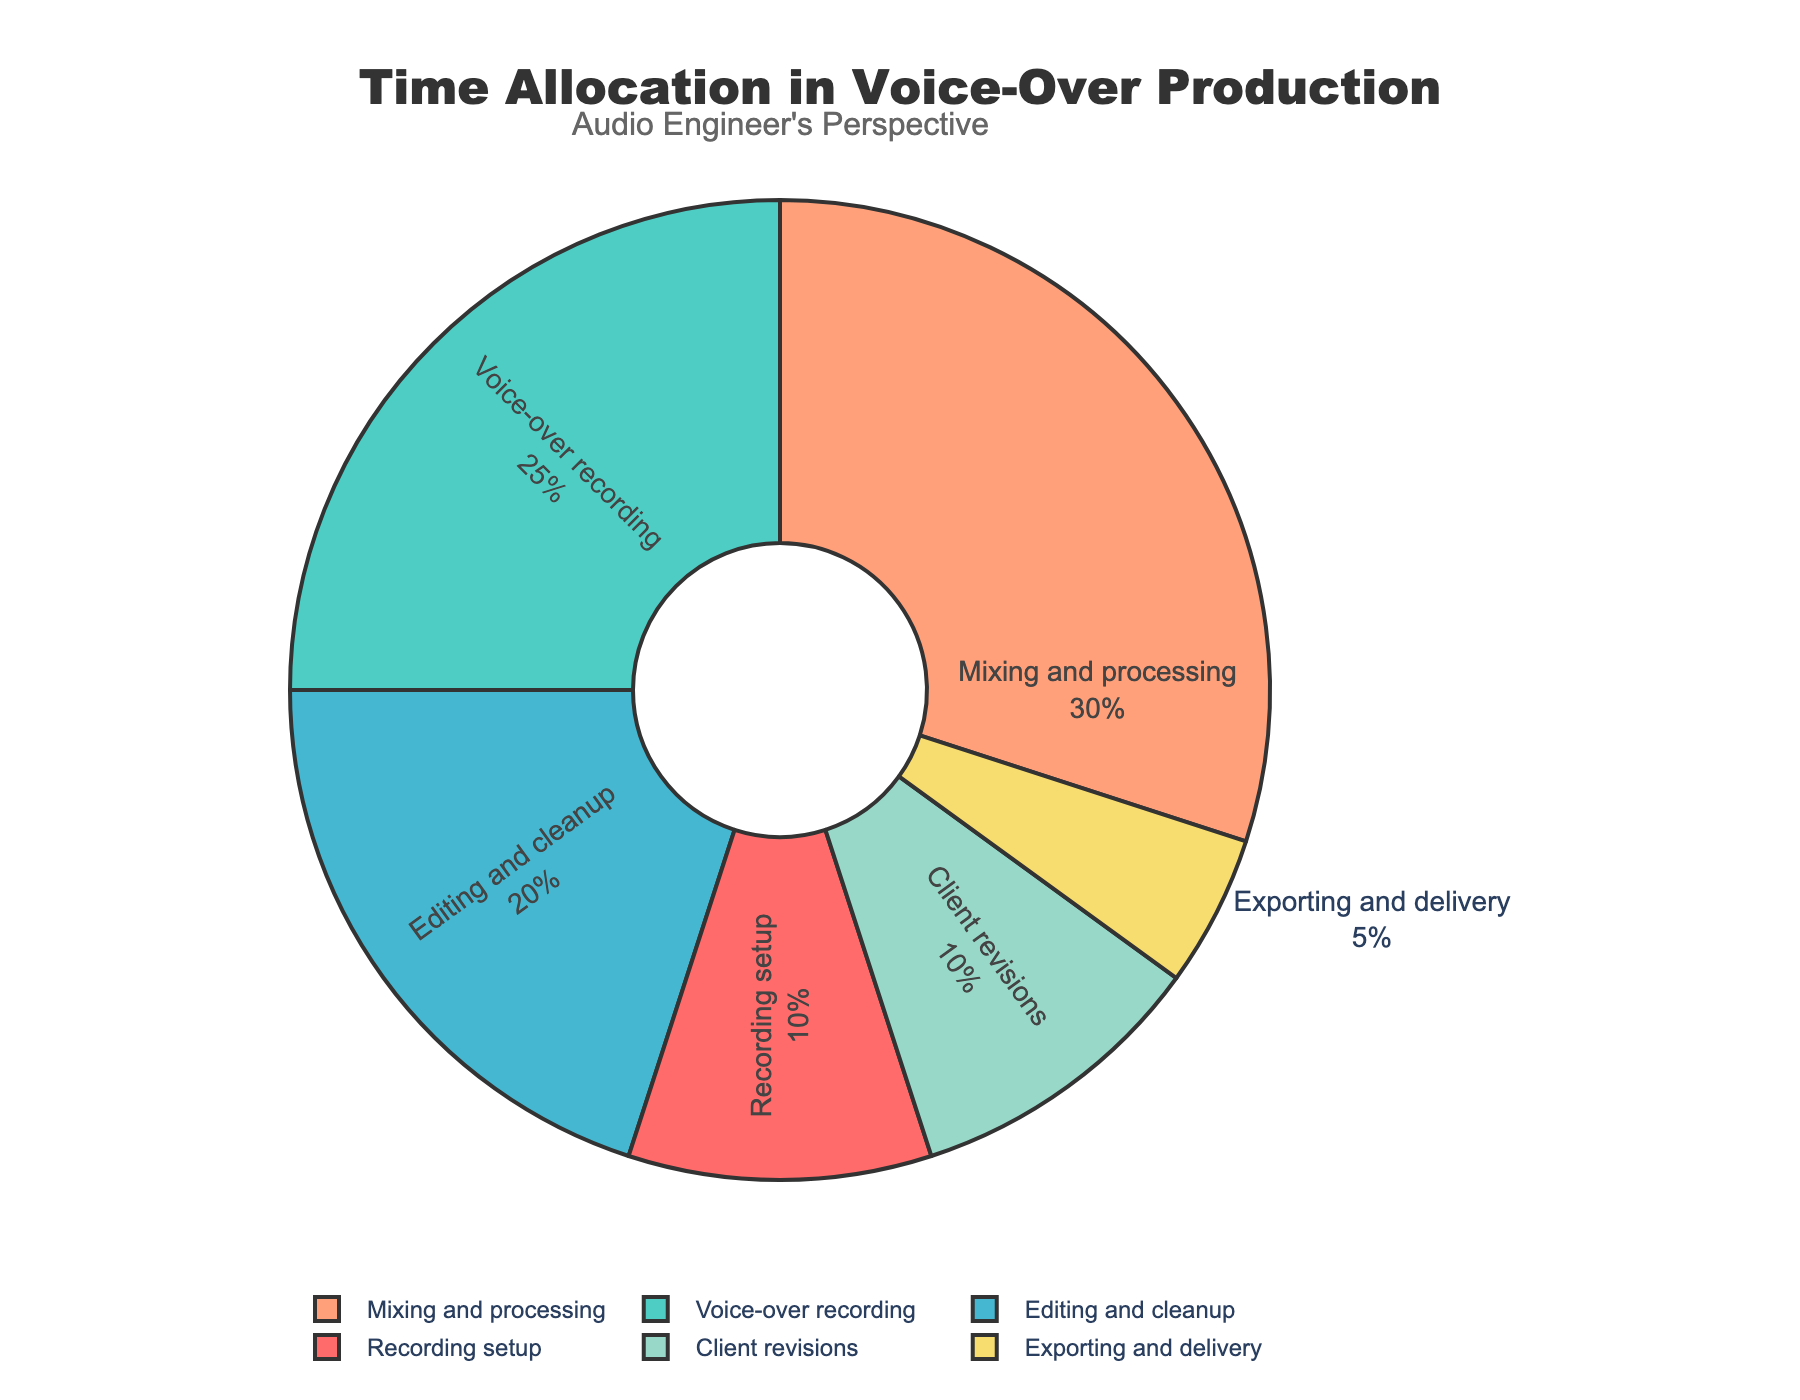What stage takes up the largest percentage of time? By examining the pie chart, we can see that "Mixing and processing" occupies the largest slice of the chart, indicating the highest percentage of time dedicated to this stage.
Answer: Mixing and processing How much more time is spent on voice-over recording compared to exporting and delivery? The pie chart shows that "Voice-over recording" is 25% and "Exporting and delivery" is 5%. The difference between these is 25% - 5% = 20%.
Answer: 20% What is the combined percentage of time spent on editing and cleanup and client revisions? By adding the percentages for "Editing and cleanup" (20%) and "Client revisions" (10%), we get a combined total of 20% + 10% = 30%.
Answer: 30% Is the time spent on recording setup more, less, or equal to the time spent on client revisions? The pie chart indicates that both "Recording setup" and "Client revisions" have equal percentages of time allocation, each being 10%.
Answer: Equal Which stage is indicated by the greenish color, and what percentage does it represent? The greenish color slice of the pie chart corresponds to the "Voice-over recording" stage, which represents 25% of the total time.
Answer: Voice-over recording, 25% What is the total percentage of time spent on tasks other than mixing and processing? To find this, subtract the percentage of "Mixing and processing" (30%) from 100%. Thus, 100% - 30% = 70%.
Answer: 70% How does the time spent on recording setup compare to that on exporting and delivery? The pie chart shows that "Recording setup" is 10% while "Exporting and delivery" is 5%, meaning recording setup takes twice as much time as exporting and delivery.
Answer: Recording setup takes twice as much time as exporting and delivery Which stage uses a yellow color, and what fraction of the total time does it represent? The yellow-colored slice on the pie chart corresponds to "Client revisions". It represents 10% of the total time. To find the fraction, 10% is equivalent to 10/100 or 1/10.
Answer: Client revisions, 1/10 What are the total percentages for stages colored in shades of blue? In the pie chart, "Voice-over recording" uses a teal color (25%), and "Mixing and processing" uses a salmon color (30%). Adding these gives us 25% + 30% = 55%.
Answer: 55% 